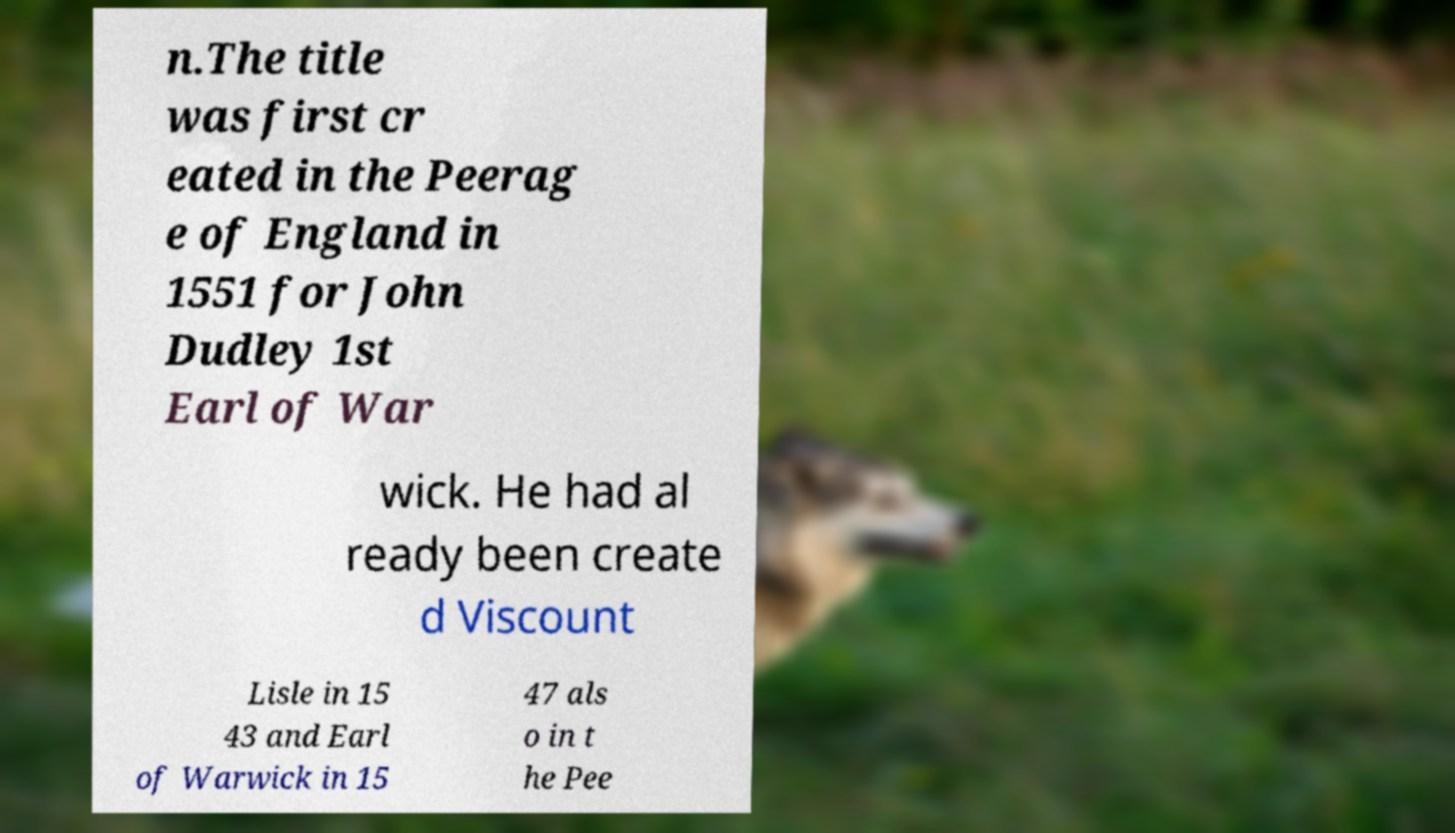I need the written content from this picture converted into text. Can you do that? n.The title was first cr eated in the Peerag e of England in 1551 for John Dudley 1st Earl of War wick. He had al ready been create d Viscount Lisle in 15 43 and Earl of Warwick in 15 47 als o in t he Pee 